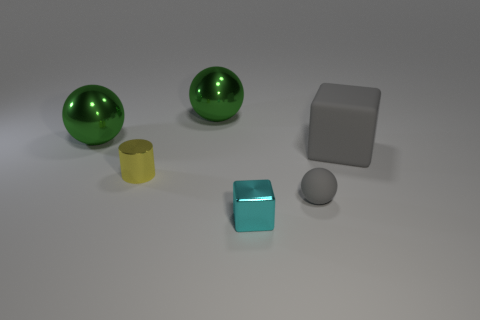Add 4 big gray matte things. How many objects exist? 10 Subtract all cylinders. How many objects are left? 5 Add 4 small gray objects. How many small gray objects exist? 5 Subtract 0 gray cylinders. How many objects are left? 6 Subtract all brown blocks. Subtract all tiny metallic things. How many objects are left? 4 Add 5 cylinders. How many cylinders are left? 6 